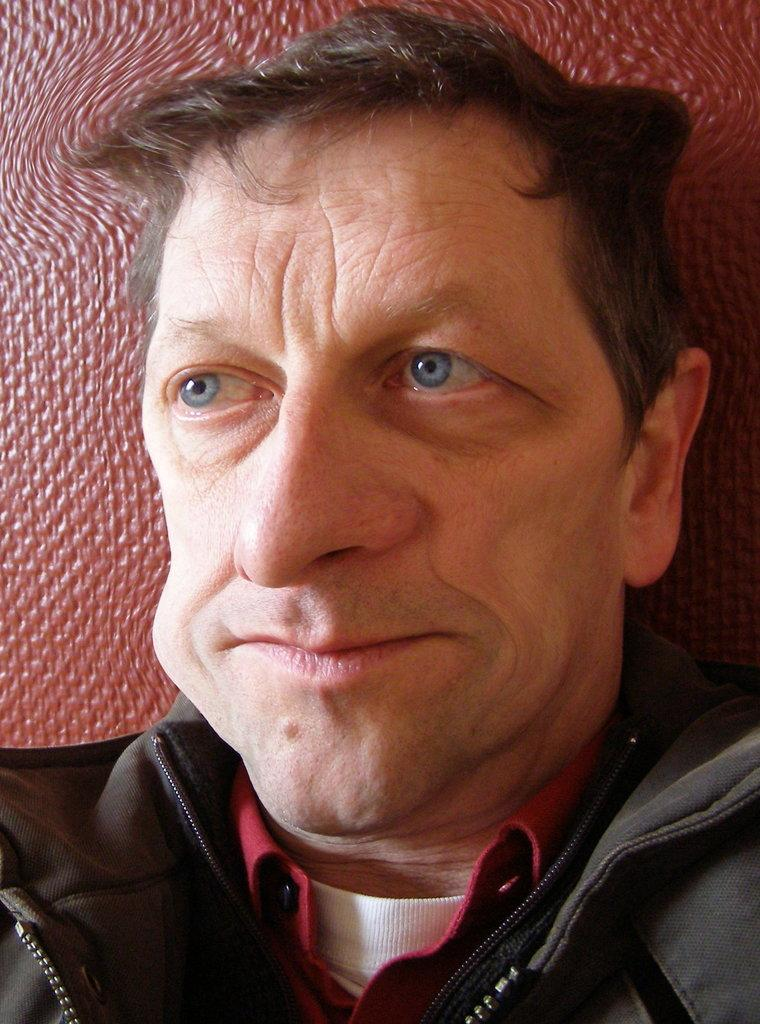Who is present in the image? There is a man in the image. What is the man wearing on his upper body? The man is wearing a red and white T-shirt and a black jacket. What is the color of the background in the image? The background of the image is brown in color. Is there any indication that the image has been altered or edited? The image might be edited, but we cannot determine that definitively from the provided facts. How many giraffes are standing next to the man in the image? There are no giraffes present in the image; it features only a man. Are the man's sisters also in the image? There is no mention of sisters or any other people in the image, so we cannot determine if they are present or not. 